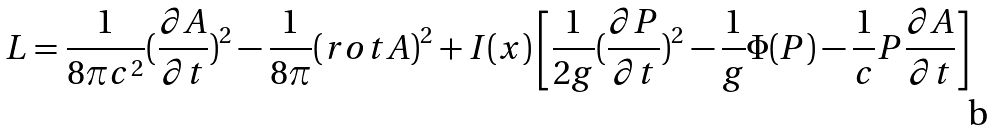Convert formula to latex. <formula><loc_0><loc_0><loc_500><loc_500>L = { \frac { 1 } { 8 \pi c ^ { 2 } } } ( \frac { \partial A } { \partial t } ) ^ { 2 } - { \frac { 1 } { 8 \pi } } ( r o t A ) ^ { 2 } + I ( { x } ) \left [ \frac { 1 } { 2 g } ( \frac { \partial P } { \partial t } ) ^ { 2 } - \frac { 1 } { g } \Phi ( P ) - { \frac { 1 } { c } } P \frac { \partial A } { \partial t } \right ]</formula> 